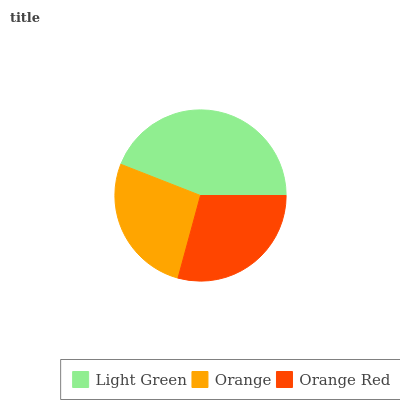Is Orange the minimum?
Answer yes or no. Yes. Is Light Green the maximum?
Answer yes or no. Yes. Is Orange Red the minimum?
Answer yes or no. No. Is Orange Red the maximum?
Answer yes or no. No. Is Orange Red greater than Orange?
Answer yes or no. Yes. Is Orange less than Orange Red?
Answer yes or no. Yes. Is Orange greater than Orange Red?
Answer yes or no. No. Is Orange Red less than Orange?
Answer yes or no. No. Is Orange Red the high median?
Answer yes or no. Yes. Is Orange Red the low median?
Answer yes or no. Yes. Is Orange the high median?
Answer yes or no. No. Is Light Green the low median?
Answer yes or no. No. 